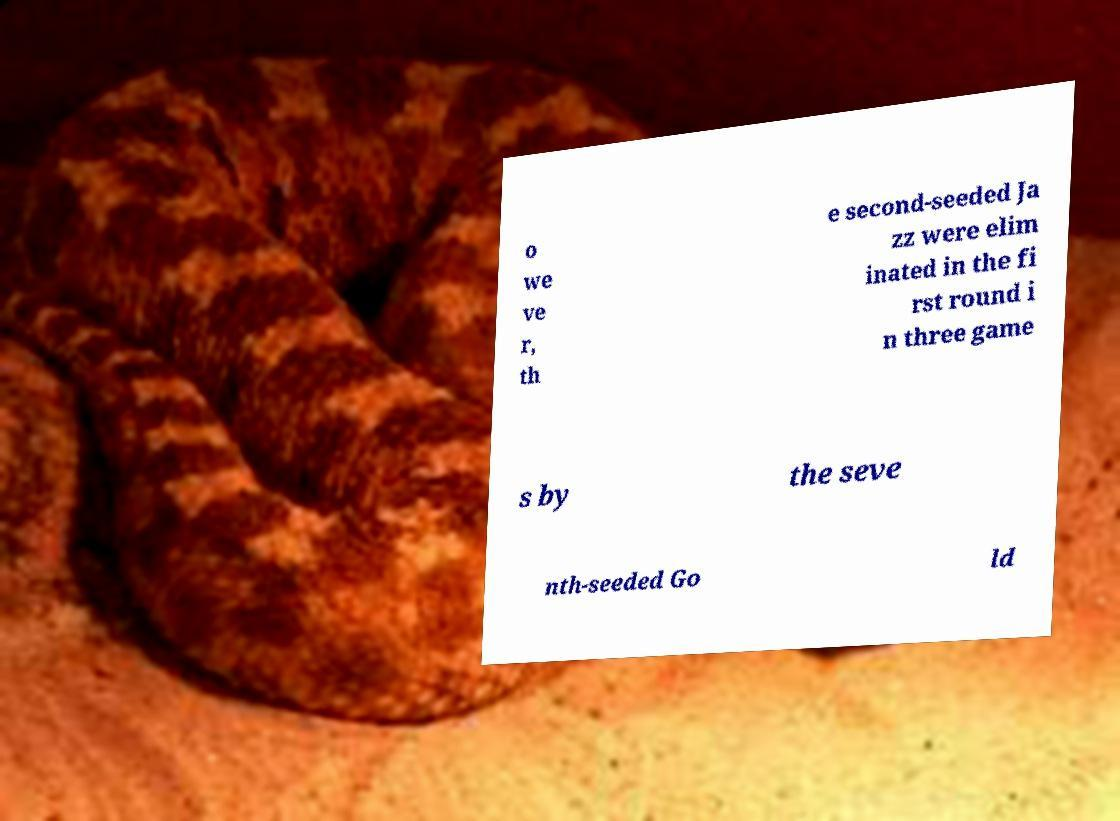Can you read and provide the text displayed in the image?This photo seems to have some interesting text. Can you extract and type it out for me? o we ve r, th e second-seeded Ja zz were elim inated in the fi rst round i n three game s by the seve nth-seeded Go ld 